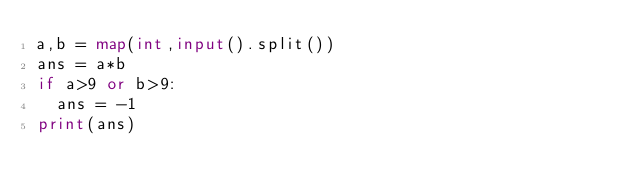Convert code to text. <code><loc_0><loc_0><loc_500><loc_500><_Python_>a,b = map(int,input().split())
ans = a*b
if a>9 or b>9:
  ans = -1
print(ans)</code> 